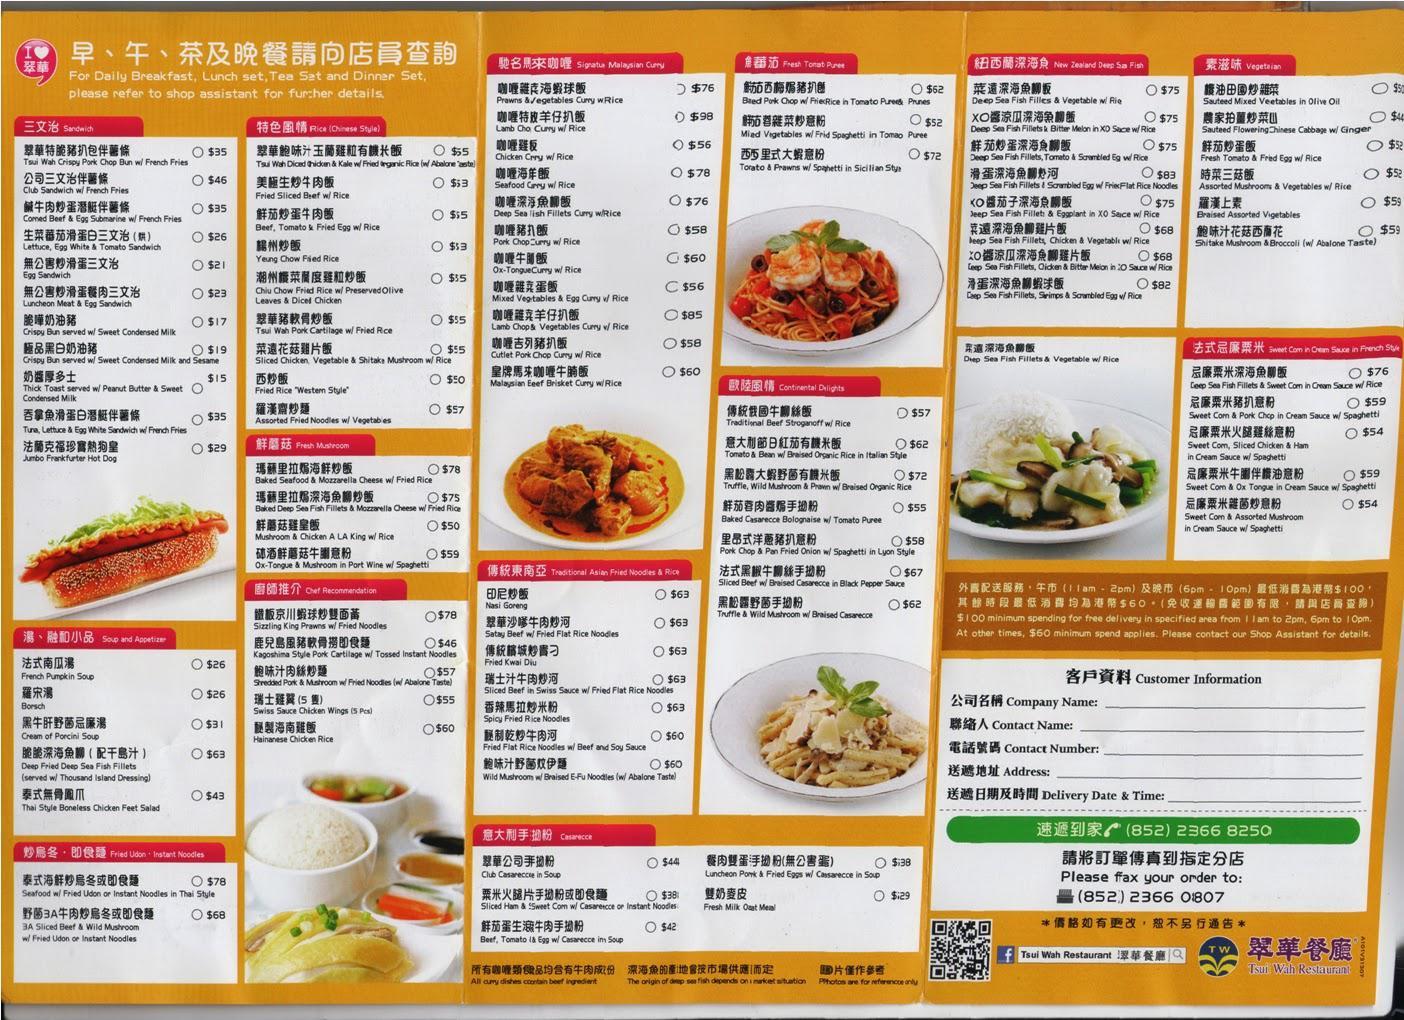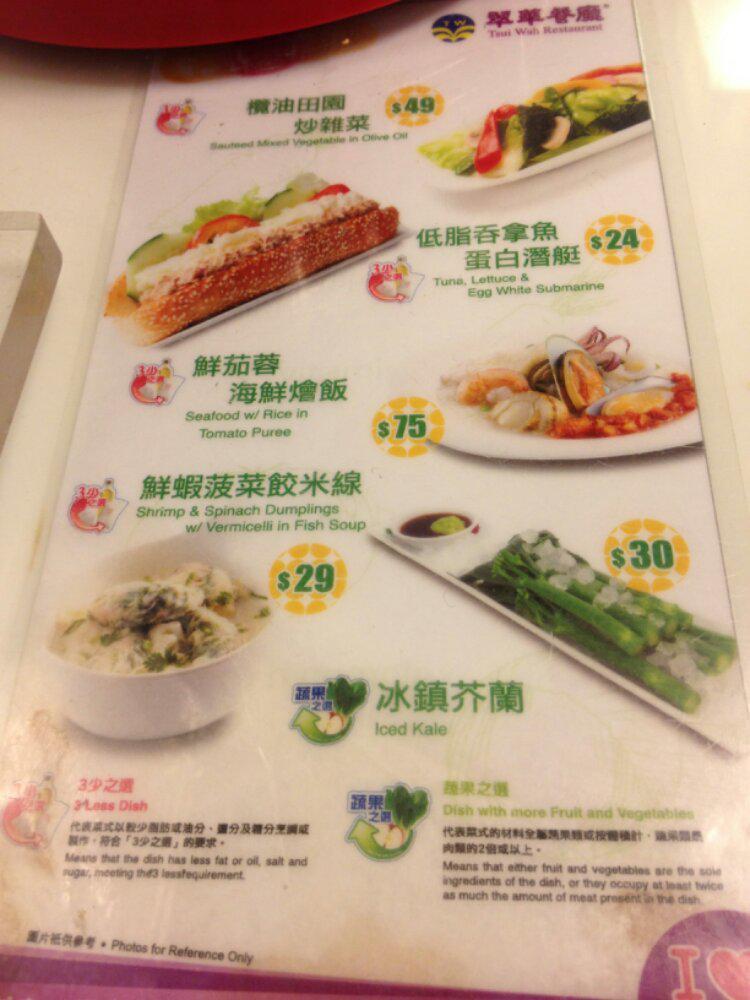The first image is the image on the left, the second image is the image on the right. Considering the images on both sides, is "One of the menus features over twenty pictures of the items." valid? Answer yes or no. No. The first image is the image on the left, the second image is the image on the right. Given the left and right images, does the statement "There are five lined menus in a row with pink headers." hold true? Answer yes or no. No. 